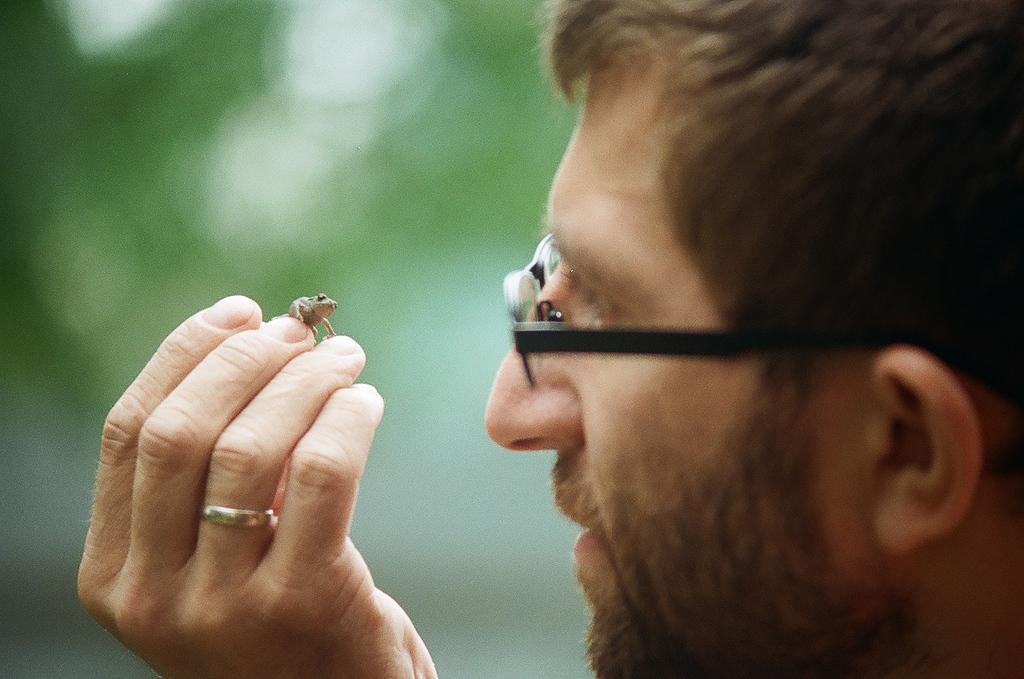Can you describe this image briefly? This image consists of a man. He is holding one animal. He is wearing specs. He has ring. 